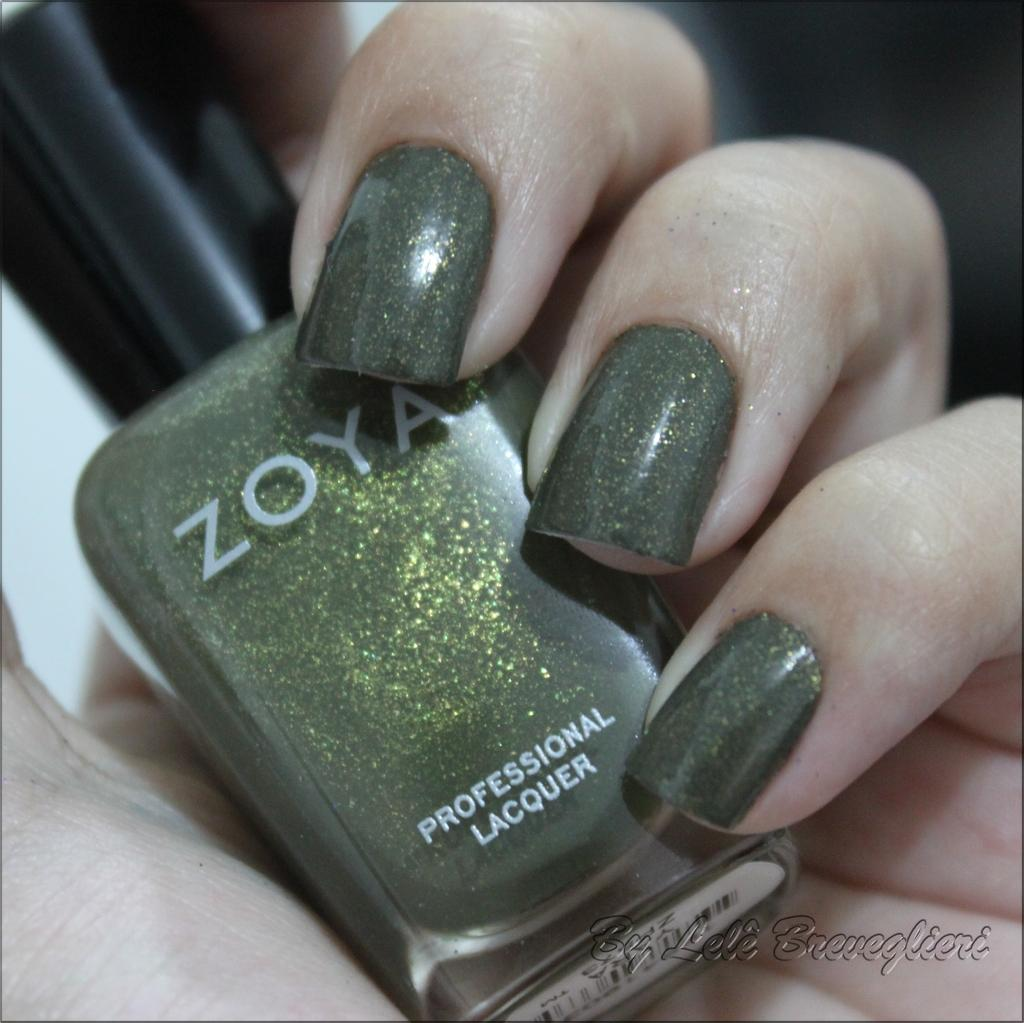What is the main subject of the image? The main subject of the image is a hand. Can you determine the gender of the hand's owner? Yes, the hand appears to belong to a woman. What object is visible in the image that might be related to the hand? There is a nail polish bottle visible in the image. What type of camera is being used by the lizards on the stage in the image? There are no lizards or stage present in the image; it features a hand and a nail polish bottle. 